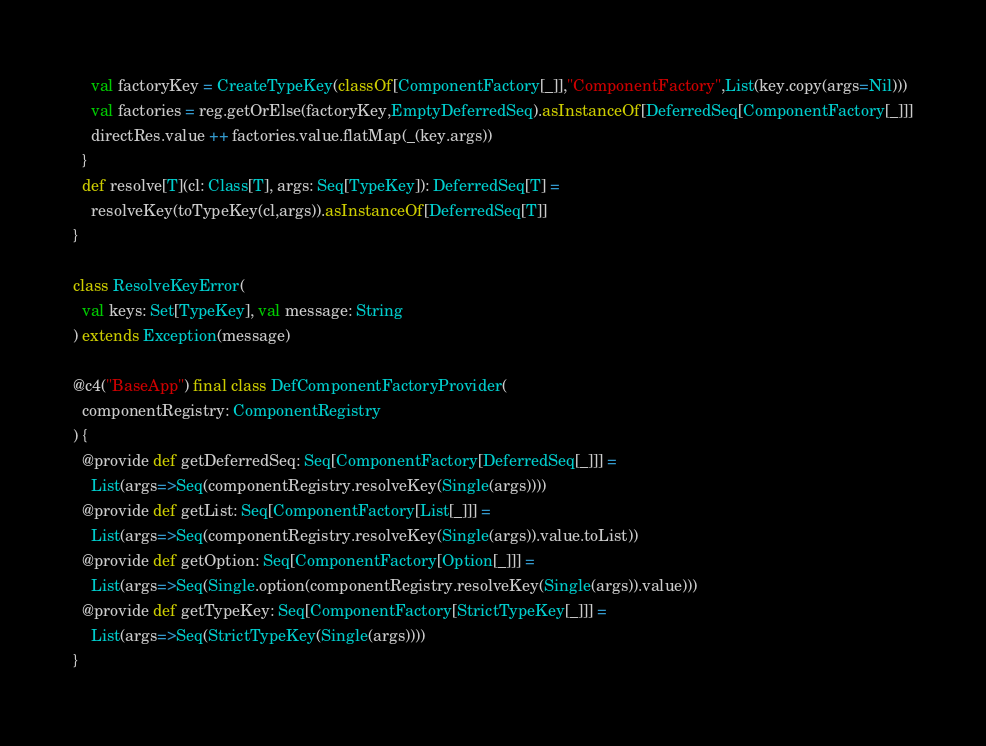Convert code to text. <code><loc_0><loc_0><loc_500><loc_500><_Scala_>    val factoryKey = CreateTypeKey(classOf[ComponentFactory[_]],"ComponentFactory",List(key.copy(args=Nil)))
    val factories = reg.getOrElse(factoryKey,EmptyDeferredSeq).asInstanceOf[DeferredSeq[ComponentFactory[_]]]
    directRes.value ++ factories.value.flatMap(_(key.args))
  }
  def resolve[T](cl: Class[T], args: Seq[TypeKey]): DeferredSeq[T] =
    resolveKey(toTypeKey(cl,args)).asInstanceOf[DeferredSeq[T]]
}

class ResolveKeyError(
  val keys: Set[TypeKey], val message: String
) extends Exception(message)

@c4("BaseApp") final class DefComponentFactoryProvider(
  componentRegistry: ComponentRegistry
) {
  @provide def getDeferredSeq: Seq[ComponentFactory[DeferredSeq[_]]] =
    List(args=>Seq(componentRegistry.resolveKey(Single(args))))
  @provide def getList: Seq[ComponentFactory[List[_]]] =
    List(args=>Seq(componentRegistry.resolveKey(Single(args)).value.toList))
  @provide def getOption: Seq[ComponentFactory[Option[_]]] =
    List(args=>Seq(Single.option(componentRegistry.resolveKey(Single(args)).value)))
  @provide def getTypeKey: Seq[ComponentFactory[StrictTypeKey[_]]] =
    List(args=>Seq(StrictTypeKey(Single(args))))
}
</code> 